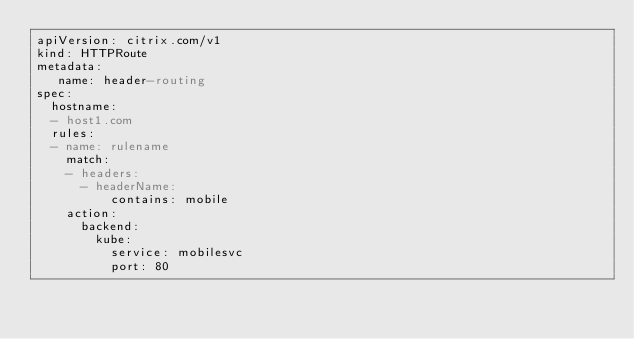Convert code to text. <code><loc_0><loc_0><loc_500><loc_500><_YAML_>apiVersion: citrix.com/v1
kind: HTTPRoute
metadata:
   name: header-routing 
spec:
  hostname:
  - host1.com
  rules:       
  - name: rulename 
    match:
    - headers:
      - headerName:
          contains: mobile 
    action:
      backend:
        kube:
          service: mobilesvc
          port: 80

</code> 